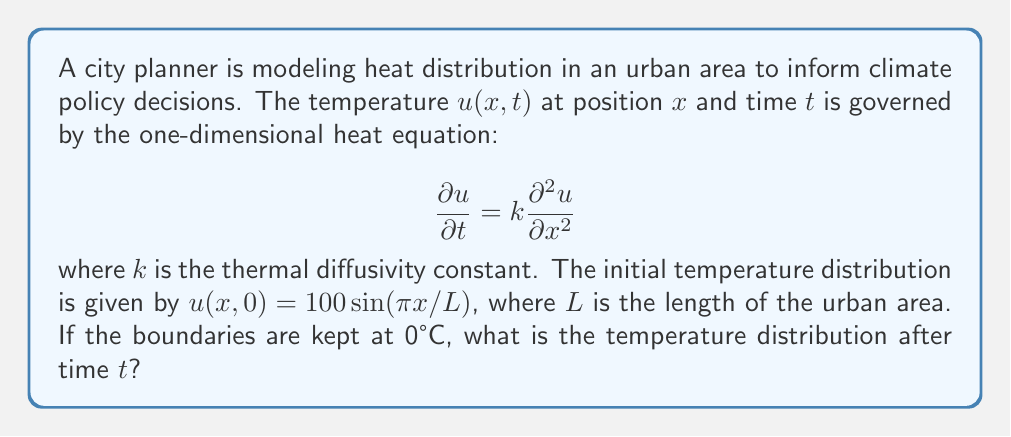Could you help me with this problem? To solve this problem, we'll follow these steps:

1) The general solution to the heat equation with the given boundary conditions is:

   $$u(x,t) = \sum_{n=1}^{\infty} B_n \sin(\frac{n\pi x}{L}) e^{-k(\frac{n\pi}{L})^2t}$$

2) We need to find $B_n$ that satisfies the initial condition:

   $$u(x,0) = 100\sin(\frac{\pi x}{L}) = \sum_{n=1}^{\infty} B_n \sin(\frac{n\pi x}{L})$$

3) Comparing the initial condition with the general solution at $t=0$, we can see that:
   
   $B_1 = 100$ and $B_n = 0$ for $n > 1$

4) Therefore, the solution simplifies to:

   $$u(x,t) = 100 \sin(\frac{\pi x}{L}) e^{-k(\frac{\pi}{L})^2t}$$

5) This equation gives the temperature distribution at any position $x$ and time $t$.
Answer: $u(x,t) = 100 \sin(\frac{\pi x}{L}) e^{-k(\frac{\pi}{L})^2t}$ 